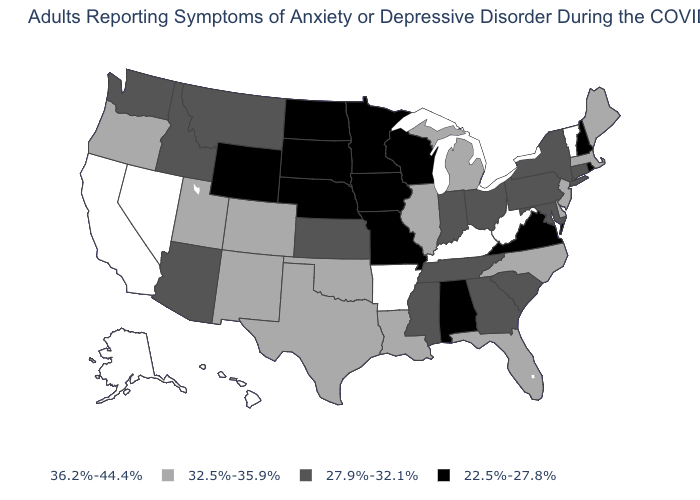Name the states that have a value in the range 32.5%-35.9%?
Short answer required. Colorado, Delaware, Florida, Illinois, Louisiana, Maine, Massachusetts, Michigan, New Jersey, New Mexico, North Carolina, Oklahoma, Oregon, Texas, Utah. Is the legend a continuous bar?
Keep it brief. No. What is the value of New York?
Answer briefly. 27.9%-32.1%. What is the value of Hawaii?
Keep it brief. 36.2%-44.4%. What is the highest value in the USA?
Write a very short answer. 36.2%-44.4%. What is the value of Idaho?
Answer briefly. 27.9%-32.1%. What is the highest value in the USA?
Give a very brief answer. 36.2%-44.4%. What is the lowest value in states that border Washington?
Concise answer only. 27.9%-32.1%. Name the states that have a value in the range 32.5%-35.9%?
Short answer required. Colorado, Delaware, Florida, Illinois, Louisiana, Maine, Massachusetts, Michigan, New Jersey, New Mexico, North Carolina, Oklahoma, Oregon, Texas, Utah. What is the lowest value in the USA?
Answer briefly. 22.5%-27.8%. Does Illinois have the lowest value in the USA?
Be succinct. No. Does the first symbol in the legend represent the smallest category?
Be succinct. No. Name the states that have a value in the range 27.9%-32.1%?
Keep it brief. Arizona, Connecticut, Georgia, Idaho, Indiana, Kansas, Maryland, Mississippi, Montana, New York, Ohio, Pennsylvania, South Carolina, Tennessee, Washington. Name the states that have a value in the range 27.9%-32.1%?
Short answer required. Arizona, Connecticut, Georgia, Idaho, Indiana, Kansas, Maryland, Mississippi, Montana, New York, Ohio, Pennsylvania, South Carolina, Tennessee, Washington. What is the value of Montana?
Keep it brief. 27.9%-32.1%. 